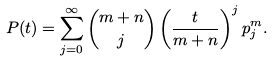<formula> <loc_0><loc_0><loc_500><loc_500>P ( t ) = \sum _ { j = 0 } ^ { \infty } \binom { m + n } { j } \left ( \frac { t } { m + n } \right ) ^ { j } p _ { j } ^ { m } .</formula> 